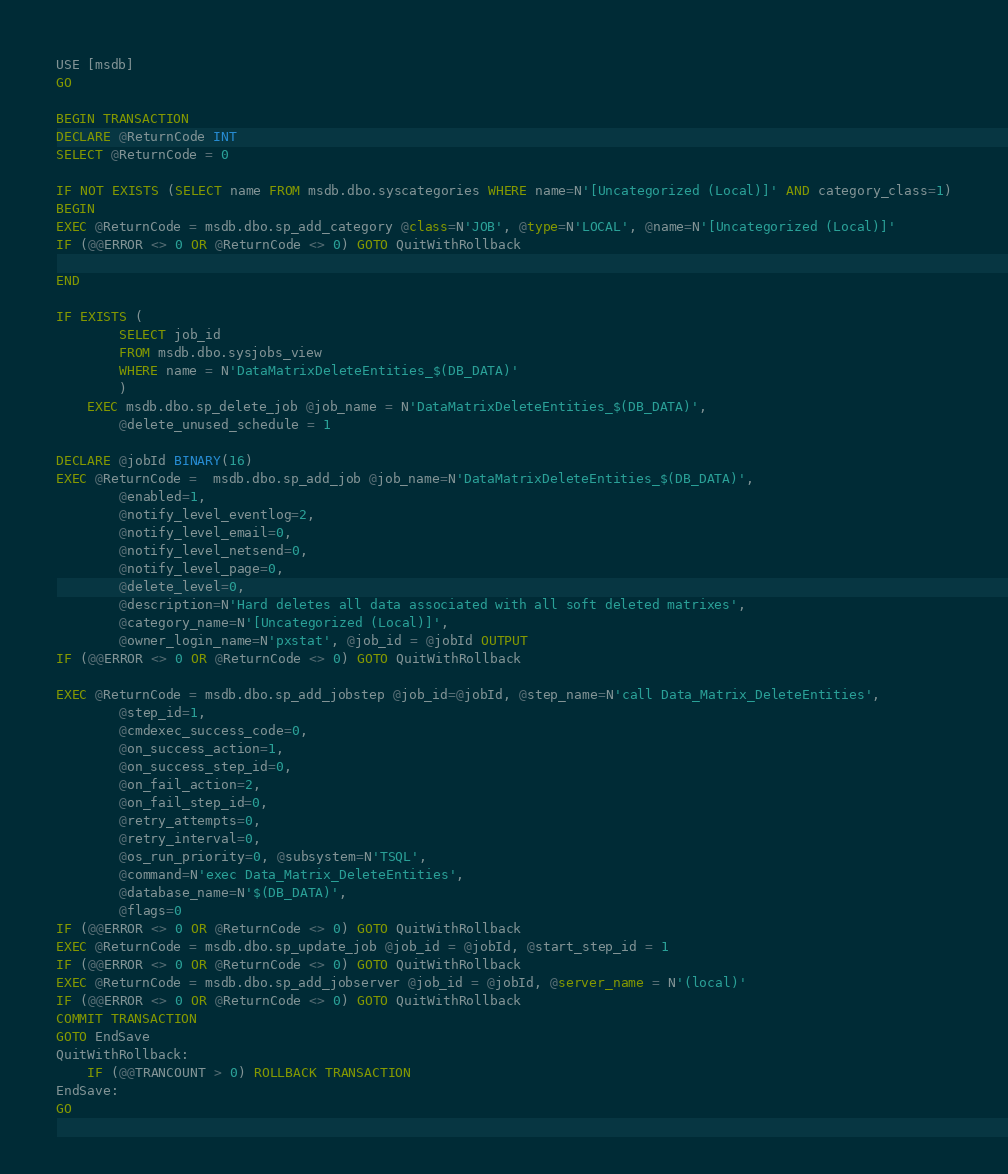Convert code to text. <code><loc_0><loc_0><loc_500><loc_500><_SQL_>USE [msdb]
GO

BEGIN TRANSACTION
DECLARE @ReturnCode INT
SELECT @ReturnCode = 0

IF NOT EXISTS (SELECT name FROM msdb.dbo.syscategories WHERE name=N'[Uncategorized (Local)]' AND category_class=1)
BEGIN
EXEC @ReturnCode = msdb.dbo.sp_add_category @class=N'JOB', @type=N'LOCAL', @name=N'[Uncategorized (Local)]'
IF (@@ERROR <> 0 OR @ReturnCode <> 0) GOTO QuitWithRollback

END

IF EXISTS (
		SELECT job_id
		FROM msdb.dbo.sysjobs_view
		WHERE name = N'DataMatrixDeleteEntities_$(DB_DATA)'
		)
	EXEC msdb.dbo.sp_delete_job @job_name = N'DataMatrixDeleteEntities_$(DB_DATA)',
		@delete_unused_schedule = 1
		
DECLARE @jobId BINARY(16)
EXEC @ReturnCode =  msdb.dbo.sp_add_job @job_name=N'DataMatrixDeleteEntities_$(DB_DATA)', 
		@enabled=1, 
		@notify_level_eventlog=2, 
		@notify_level_email=0, 
		@notify_level_netsend=0, 
		@notify_level_page=0, 
		@delete_level=0, 
		@description=N'Hard deletes all data associated with all soft deleted matrixes', 
		@category_name=N'[Uncategorized (Local)]', 
		@owner_login_name=N'pxstat', @job_id = @jobId OUTPUT
IF (@@ERROR <> 0 OR @ReturnCode <> 0) GOTO QuitWithRollback

EXEC @ReturnCode = msdb.dbo.sp_add_jobstep @job_id=@jobId, @step_name=N'call Data_Matrix_DeleteEntities', 
		@step_id=1, 
		@cmdexec_success_code=0, 
		@on_success_action=1, 
		@on_success_step_id=0, 
		@on_fail_action=2, 
		@on_fail_step_id=0, 
		@retry_attempts=0, 
		@retry_interval=0, 
		@os_run_priority=0, @subsystem=N'TSQL', 
		@command=N'exec Data_Matrix_DeleteEntities', 
		@database_name=N'$(DB_DATA)', 
		@flags=0
IF (@@ERROR <> 0 OR @ReturnCode <> 0) GOTO QuitWithRollback
EXEC @ReturnCode = msdb.dbo.sp_update_job @job_id = @jobId, @start_step_id = 1
IF (@@ERROR <> 0 OR @ReturnCode <> 0) GOTO QuitWithRollback
EXEC @ReturnCode = msdb.dbo.sp_add_jobserver @job_id = @jobId, @server_name = N'(local)'
IF (@@ERROR <> 0 OR @ReturnCode <> 0) GOTO QuitWithRollback
COMMIT TRANSACTION
GOTO EndSave
QuitWithRollback:
    IF (@@TRANCOUNT > 0) ROLLBACK TRANSACTION
EndSave:
GO


</code> 